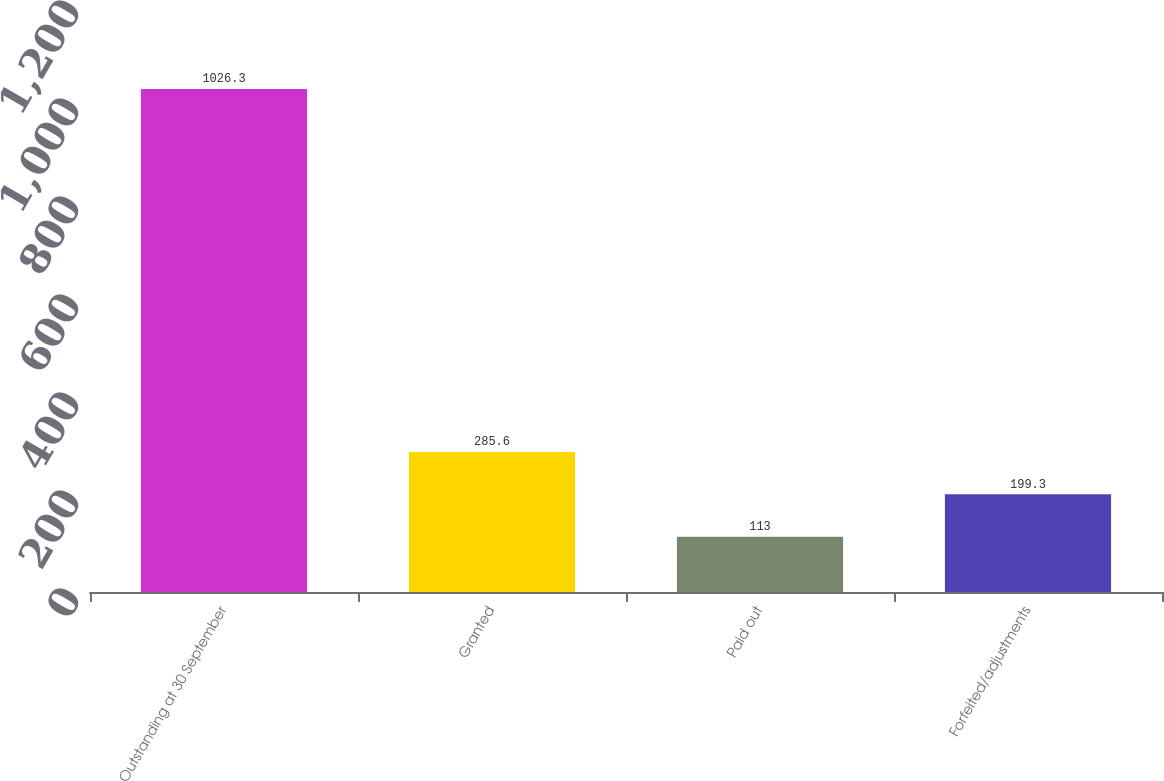Convert chart. <chart><loc_0><loc_0><loc_500><loc_500><bar_chart><fcel>Outstanding at 30 September<fcel>Granted<fcel>Paid out<fcel>Forfeited/adjustments<nl><fcel>1026.3<fcel>285.6<fcel>113<fcel>199.3<nl></chart> 